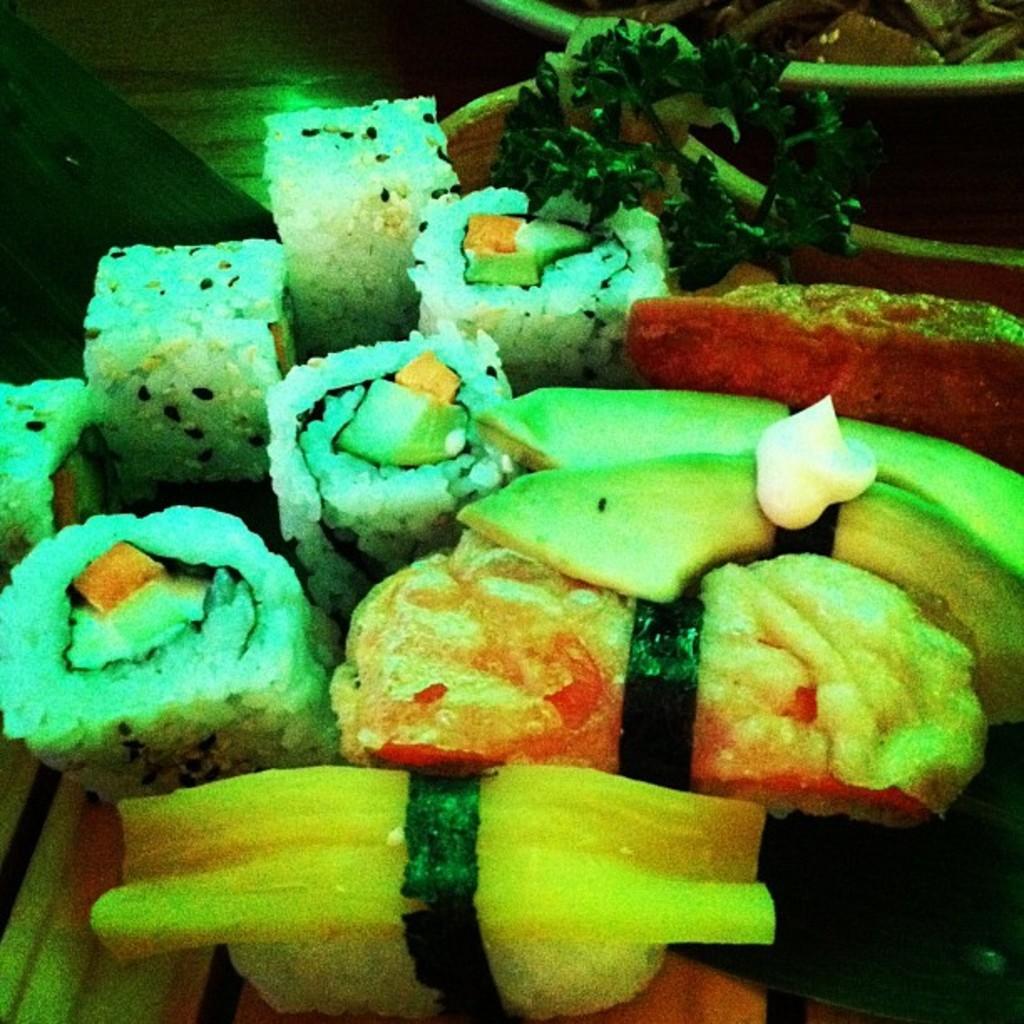How would you summarize this image in a sentence or two? In this image, I can see sushi and some other food items in a bowl. This looks like a wooden board. I think there is another plate. 